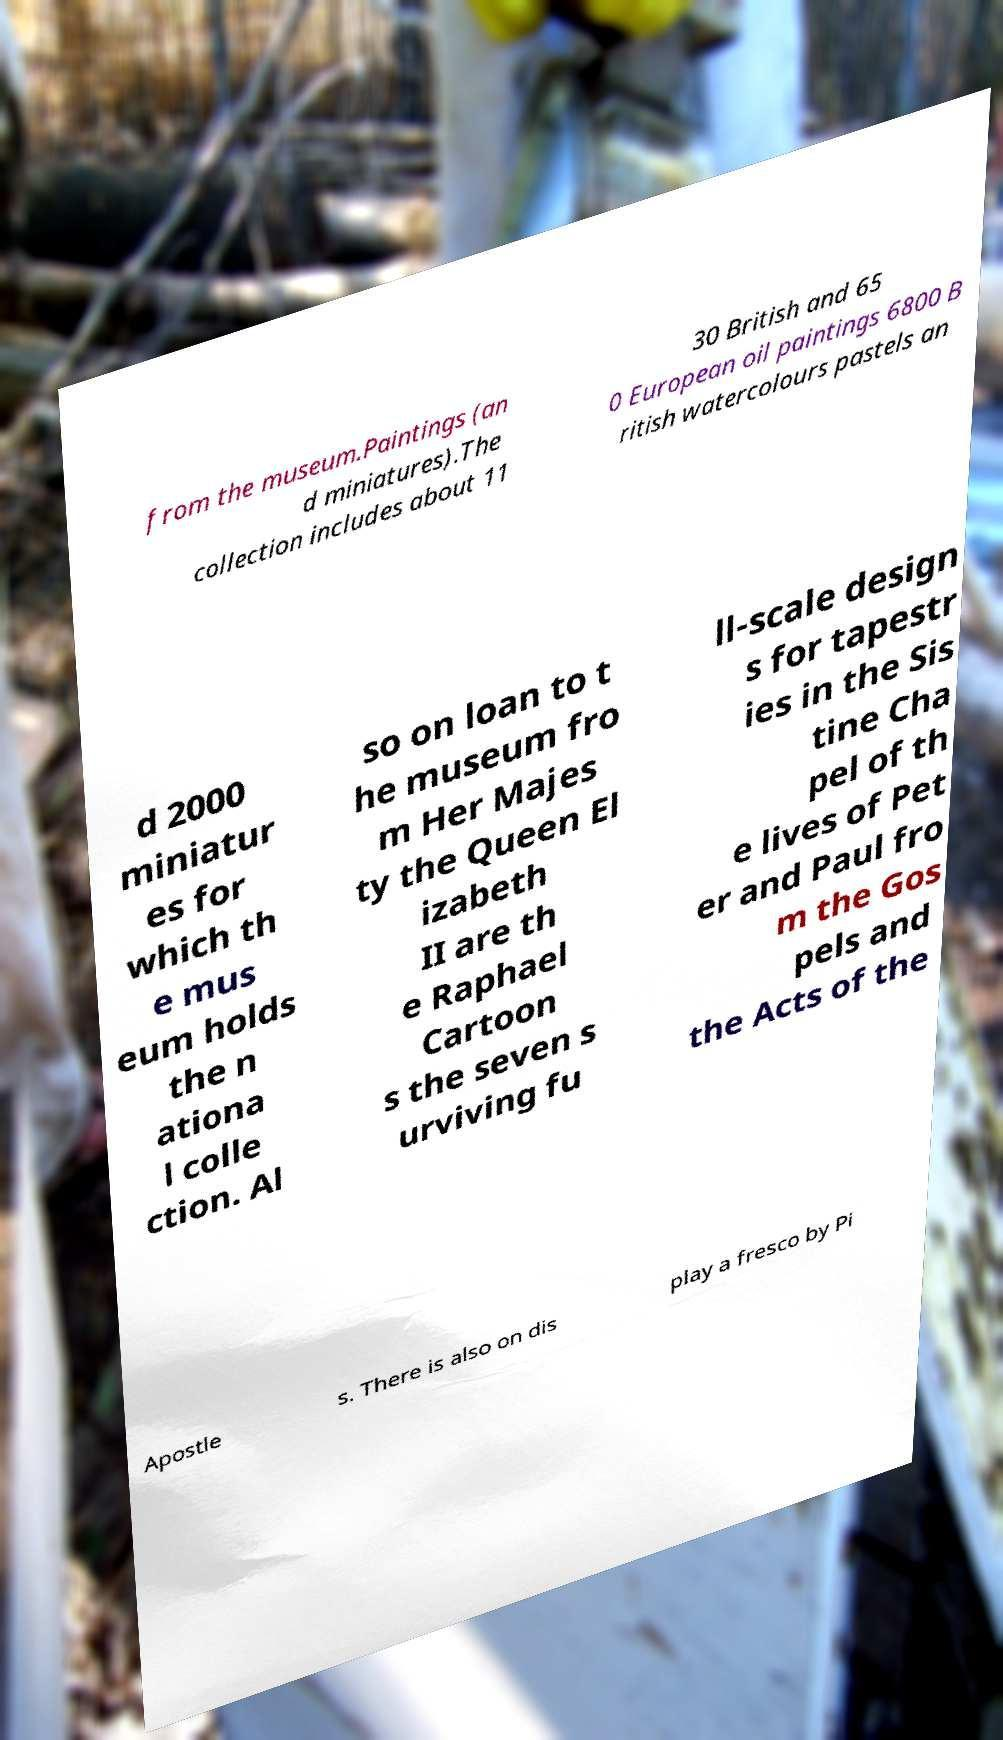For documentation purposes, I need the text within this image transcribed. Could you provide that? from the museum.Paintings (an d miniatures).The collection includes about 11 30 British and 65 0 European oil paintings 6800 B ritish watercolours pastels an d 2000 miniatur es for which th e mus eum holds the n ationa l colle ction. Al so on loan to t he museum fro m Her Majes ty the Queen El izabeth II are th e Raphael Cartoon s the seven s urviving fu ll-scale design s for tapestr ies in the Sis tine Cha pel of th e lives of Pet er and Paul fro m the Gos pels and the Acts of the Apostle s. There is also on dis play a fresco by Pi 